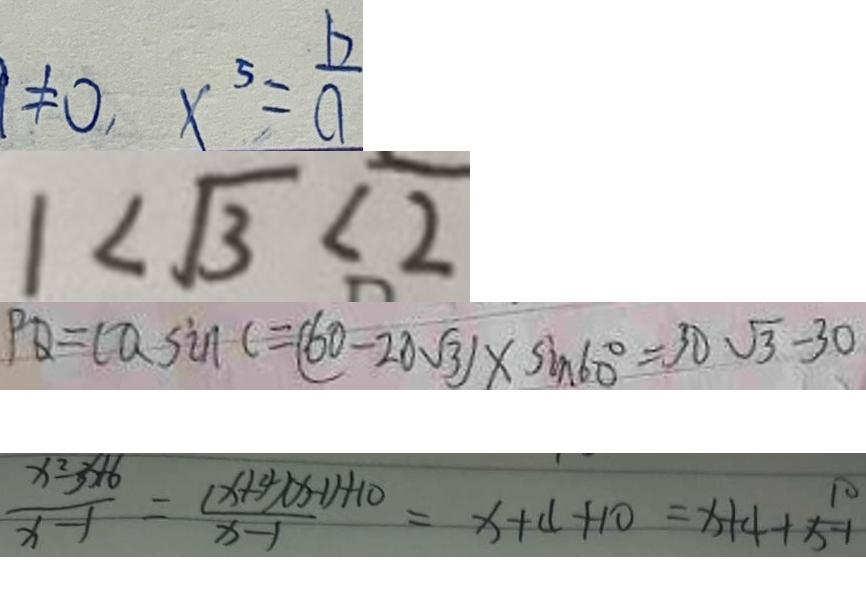Convert formula to latex. <formula><loc_0><loc_0><loc_500><loc_500>\neq 0 x ^ { 5 } = \frac { b } { a } 
 1 < \sqrt { 3 } < 2 
 P Q = C Q \sin C = ( 6 0 - 2 0 \sqrt { 3 } ) \times \sin 6 0 ^ { \circ } = 3 0 \sqrt { 3 } - 3 0 
 \frac { x ^ { 2 } - 3 + 6 } { x - 1 } = \frac { ( x + 4 ) ( x - 1 ) + 1 0 } { x - 1 } = x + 4 + 1 0 = x + 4 + \frac { 1 0 } { x - 1 }</formula> 